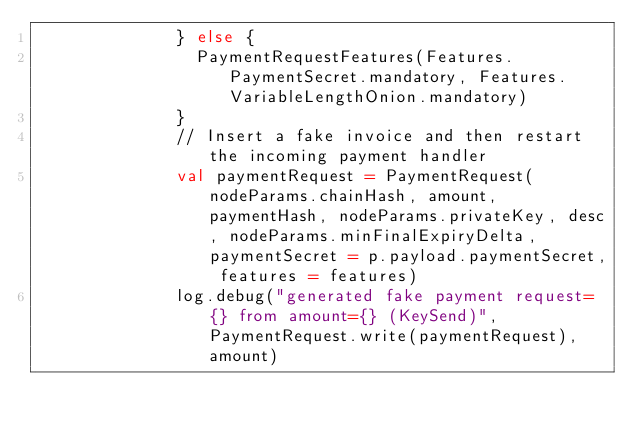Convert code to text. <code><loc_0><loc_0><loc_500><loc_500><_Scala_>              } else {
                PaymentRequestFeatures(Features.PaymentSecret.mandatory, Features.VariableLengthOnion.mandatory)
              }
              // Insert a fake invoice and then restart the incoming payment handler
              val paymentRequest = PaymentRequest(nodeParams.chainHash, amount, paymentHash, nodeParams.privateKey, desc, nodeParams.minFinalExpiryDelta, paymentSecret = p.payload.paymentSecret, features = features)
              log.debug("generated fake payment request={} from amount={} (KeySend)", PaymentRequest.write(paymentRequest), amount)</code> 